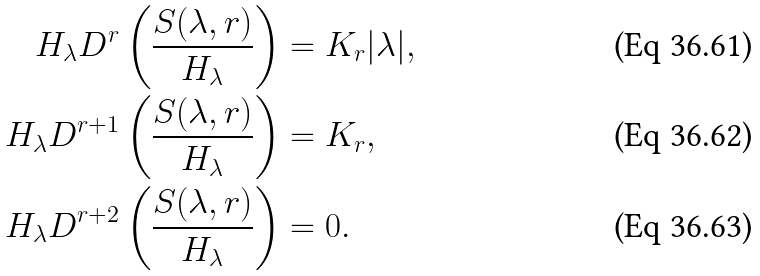Convert formula to latex. <formula><loc_0><loc_0><loc_500><loc_500>H _ { \lambda } D ^ { r } \left ( \frac { S ( \lambda , r ) } { H _ { \lambda } } \right ) & = K _ { r } | \lambda | , \\ H _ { \lambda } D ^ { r + 1 } \left ( \frac { S ( \lambda , r ) } { H _ { \lambda } } \right ) & = K _ { r } , \\ H _ { \lambda } D ^ { r + 2 } \left ( \frac { S ( \lambda , r ) } { H _ { \lambda } } \right ) & = 0 .</formula> 